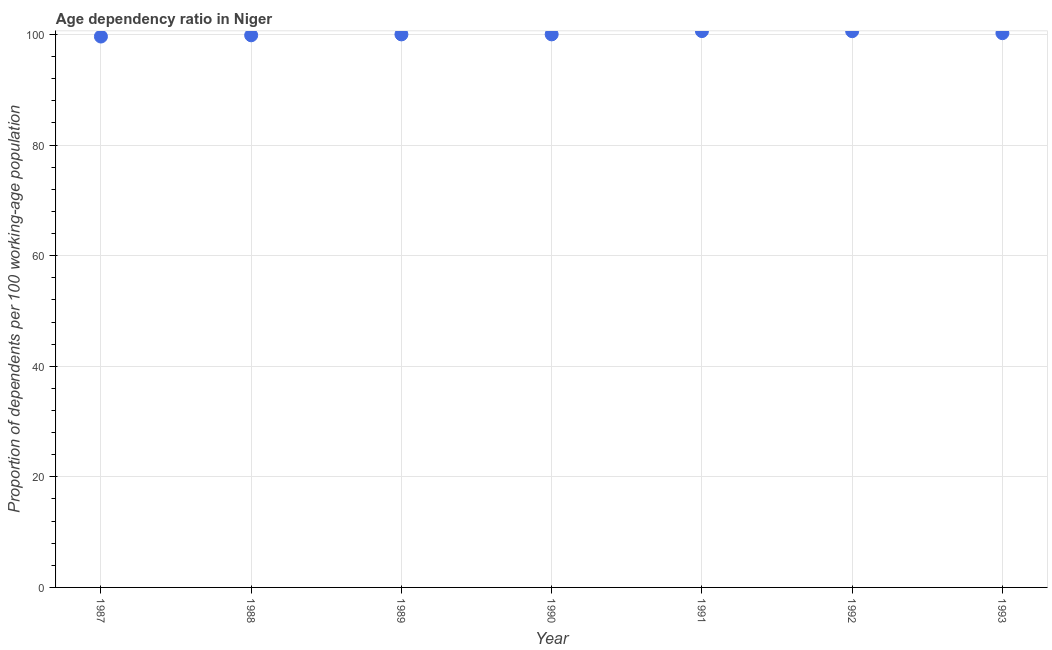What is the age dependency ratio in 1988?
Ensure brevity in your answer.  99.85. Across all years, what is the maximum age dependency ratio?
Ensure brevity in your answer.  100.62. Across all years, what is the minimum age dependency ratio?
Give a very brief answer. 99.63. In which year was the age dependency ratio minimum?
Keep it short and to the point. 1987. What is the sum of the age dependency ratio?
Offer a terse response. 700.99. What is the difference between the age dependency ratio in 1988 and 1992?
Ensure brevity in your answer.  -0.74. What is the average age dependency ratio per year?
Offer a very short reply. 100.14. What is the median age dependency ratio?
Ensure brevity in your answer.  100.02. In how many years, is the age dependency ratio greater than 84 ?
Provide a short and direct response. 7. What is the ratio of the age dependency ratio in 1990 to that in 1992?
Offer a terse response. 0.99. Is the age dependency ratio in 1991 less than that in 1992?
Provide a short and direct response. No. Is the difference between the age dependency ratio in 1989 and 1993 greater than the difference between any two years?
Offer a very short reply. No. What is the difference between the highest and the second highest age dependency ratio?
Provide a succinct answer. 0.02. What is the difference between the highest and the lowest age dependency ratio?
Offer a very short reply. 0.98. In how many years, is the age dependency ratio greater than the average age dependency ratio taken over all years?
Provide a succinct answer. 3. Does the age dependency ratio monotonically increase over the years?
Give a very brief answer. No. How many dotlines are there?
Offer a very short reply. 1. How many years are there in the graph?
Provide a short and direct response. 7. What is the difference between two consecutive major ticks on the Y-axis?
Keep it short and to the point. 20. Are the values on the major ticks of Y-axis written in scientific E-notation?
Your answer should be very brief. No. What is the title of the graph?
Offer a terse response. Age dependency ratio in Niger. What is the label or title of the Y-axis?
Your answer should be very brief. Proportion of dependents per 100 working-age population. What is the Proportion of dependents per 100 working-age population in 1987?
Offer a terse response. 99.63. What is the Proportion of dependents per 100 working-age population in 1988?
Keep it short and to the point. 99.85. What is the Proportion of dependents per 100 working-age population in 1989?
Make the answer very short. 100.02. What is the Proportion of dependents per 100 working-age population in 1990?
Make the answer very short. 100.02. What is the Proportion of dependents per 100 working-age population in 1991?
Your answer should be very brief. 100.62. What is the Proportion of dependents per 100 working-age population in 1992?
Your answer should be very brief. 100.6. What is the Proportion of dependents per 100 working-age population in 1993?
Your response must be concise. 100.24. What is the difference between the Proportion of dependents per 100 working-age population in 1987 and 1988?
Your answer should be very brief. -0.22. What is the difference between the Proportion of dependents per 100 working-age population in 1987 and 1989?
Keep it short and to the point. -0.39. What is the difference between the Proportion of dependents per 100 working-age population in 1987 and 1990?
Offer a terse response. -0.39. What is the difference between the Proportion of dependents per 100 working-age population in 1987 and 1991?
Give a very brief answer. -0.98. What is the difference between the Proportion of dependents per 100 working-age population in 1987 and 1992?
Your response must be concise. -0.97. What is the difference between the Proportion of dependents per 100 working-age population in 1987 and 1993?
Provide a succinct answer. -0.61. What is the difference between the Proportion of dependents per 100 working-age population in 1988 and 1989?
Keep it short and to the point. -0.17. What is the difference between the Proportion of dependents per 100 working-age population in 1988 and 1990?
Your answer should be compact. -0.17. What is the difference between the Proportion of dependents per 100 working-age population in 1988 and 1991?
Provide a short and direct response. -0.76. What is the difference between the Proportion of dependents per 100 working-age population in 1988 and 1992?
Your response must be concise. -0.74. What is the difference between the Proportion of dependents per 100 working-age population in 1988 and 1993?
Your answer should be compact. -0.39. What is the difference between the Proportion of dependents per 100 working-age population in 1989 and 1990?
Offer a very short reply. -0. What is the difference between the Proportion of dependents per 100 working-age population in 1989 and 1991?
Your answer should be very brief. -0.6. What is the difference between the Proportion of dependents per 100 working-age population in 1989 and 1992?
Make the answer very short. -0.58. What is the difference between the Proportion of dependents per 100 working-age population in 1989 and 1993?
Give a very brief answer. -0.22. What is the difference between the Proportion of dependents per 100 working-age population in 1990 and 1991?
Make the answer very short. -0.59. What is the difference between the Proportion of dependents per 100 working-age population in 1990 and 1992?
Offer a terse response. -0.58. What is the difference between the Proportion of dependents per 100 working-age population in 1990 and 1993?
Offer a terse response. -0.22. What is the difference between the Proportion of dependents per 100 working-age population in 1991 and 1992?
Keep it short and to the point. 0.02. What is the difference between the Proportion of dependents per 100 working-age population in 1991 and 1993?
Provide a short and direct response. 0.37. What is the difference between the Proportion of dependents per 100 working-age population in 1992 and 1993?
Provide a short and direct response. 0.36. What is the ratio of the Proportion of dependents per 100 working-age population in 1987 to that in 1988?
Offer a very short reply. 1. What is the ratio of the Proportion of dependents per 100 working-age population in 1987 to that in 1990?
Give a very brief answer. 1. What is the ratio of the Proportion of dependents per 100 working-age population in 1987 to that in 1992?
Provide a succinct answer. 0.99. What is the ratio of the Proportion of dependents per 100 working-age population in 1988 to that in 1989?
Ensure brevity in your answer.  1. What is the ratio of the Proportion of dependents per 100 working-age population in 1988 to that in 1990?
Your answer should be very brief. 1. What is the ratio of the Proportion of dependents per 100 working-age population in 1988 to that in 1991?
Give a very brief answer. 0.99. What is the ratio of the Proportion of dependents per 100 working-age population in 1989 to that in 1990?
Make the answer very short. 1. What is the ratio of the Proportion of dependents per 100 working-age population in 1989 to that in 1991?
Your answer should be compact. 0.99. What is the ratio of the Proportion of dependents per 100 working-age population in 1989 to that in 1992?
Ensure brevity in your answer.  0.99. What is the ratio of the Proportion of dependents per 100 working-age population in 1989 to that in 1993?
Provide a short and direct response. 1. What is the ratio of the Proportion of dependents per 100 working-age population in 1990 to that in 1993?
Your answer should be very brief. 1. What is the ratio of the Proportion of dependents per 100 working-age population in 1991 to that in 1992?
Ensure brevity in your answer.  1. What is the ratio of the Proportion of dependents per 100 working-age population in 1991 to that in 1993?
Offer a terse response. 1. 